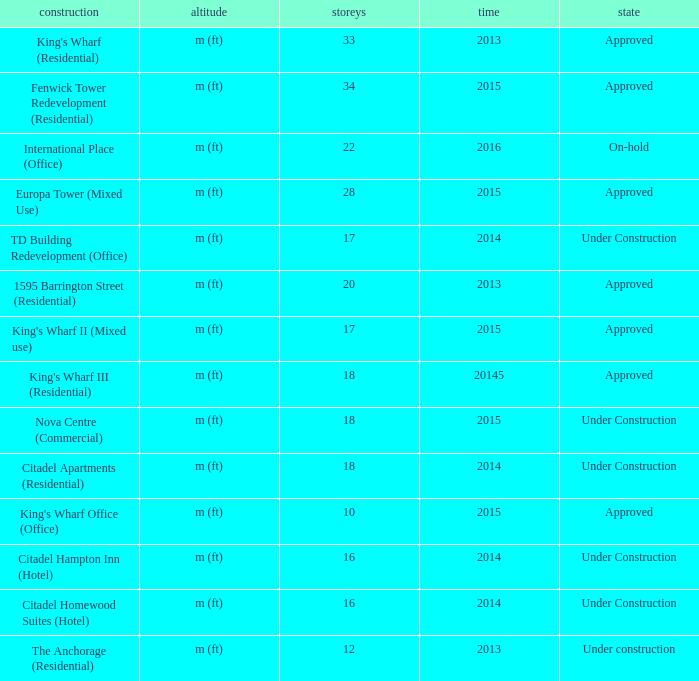Write the full table. {'header': ['construction', 'altitude', 'storeys', 'time', 'state'], 'rows': [["King's Wharf (Residential)", 'm (ft)', '33', '2013', 'Approved'], ['Fenwick Tower Redevelopment (Residential)', 'm (ft)', '34', '2015', 'Approved'], ['International Place (Office)', 'm (ft)', '22', '2016', 'On-hold'], ['Europa Tower (Mixed Use)', 'm (ft)', '28', '2015', 'Approved'], ['TD Building Redevelopment (Office)', 'm (ft)', '17', '2014', 'Under Construction'], ['1595 Barrington Street (Residential)', 'm (ft)', '20', '2013', 'Approved'], ["King's Wharf II (Mixed use)", 'm (ft)', '17', '2015', 'Approved'], ["King's Wharf III (Residential)", 'm (ft)', '18', '20145', 'Approved'], ['Nova Centre (Commercial)', 'm (ft)', '18', '2015', 'Under Construction'], ['Citadel Apartments (Residential)', 'm (ft)', '18', '2014', 'Under Construction'], ["King's Wharf Office (Office)", 'm (ft)', '10', '2015', 'Approved'], ['Citadel Hampton Inn (Hotel)', 'm (ft)', '16', '2014', 'Under Construction'], ['Citadel Homewood Suites (Hotel)', 'm (ft)', '16', '2014', 'Under Construction'], ['The Anchorage (Residential)', 'm (ft)', '12', '2013', 'Under construction']]} What is the status of the building for 2014 with 33 floors? Approved. 